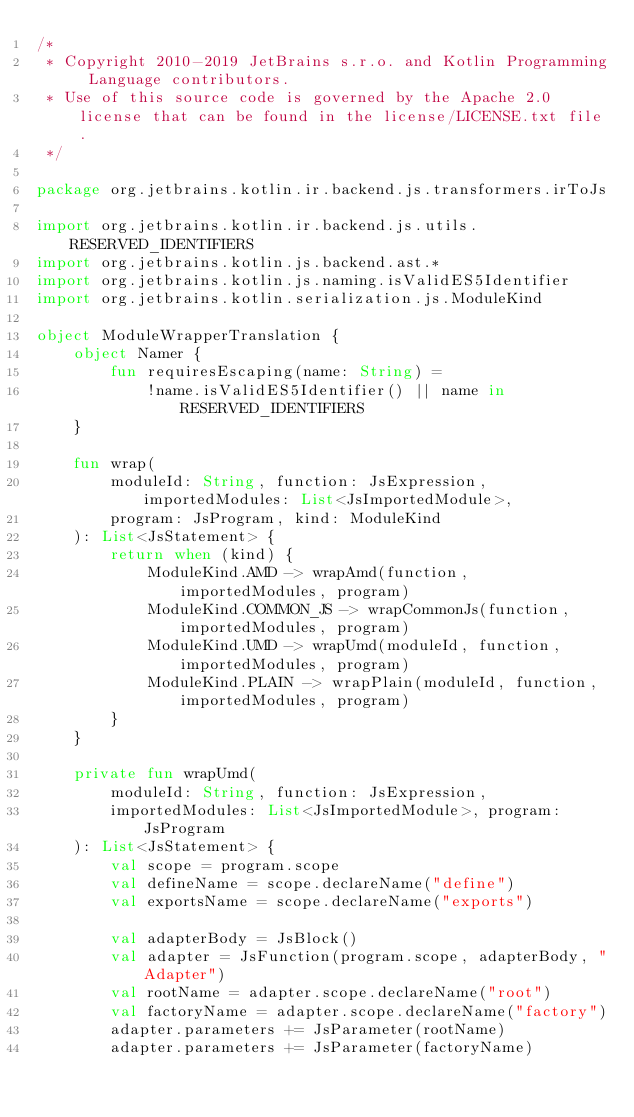Convert code to text. <code><loc_0><loc_0><loc_500><loc_500><_Kotlin_>/*
 * Copyright 2010-2019 JetBrains s.r.o. and Kotlin Programming Language contributors.
 * Use of this source code is governed by the Apache 2.0 license that can be found in the license/LICENSE.txt file.
 */

package org.jetbrains.kotlin.ir.backend.js.transformers.irToJs

import org.jetbrains.kotlin.ir.backend.js.utils.RESERVED_IDENTIFIERS
import org.jetbrains.kotlin.js.backend.ast.*
import org.jetbrains.kotlin.js.naming.isValidES5Identifier
import org.jetbrains.kotlin.serialization.js.ModuleKind

object ModuleWrapperTranslation {
    object Namer {
        fun requiresEscaping(name: String) =
            !name.isValidES5Identifier() || name in RESERVED_IDENTIFIERS
    }

    fun wrap(
        moduleId: String, function: JsExpression, importedModules: List<JsImportedModule>,
        program: JsProgram, kind: ModuleKind
    ): List<JsStatement> {
        return when (kind) {
            ModuleKind.AMD -> wrapAmd(function, importedModules, program)
            ModuleKind.COMMON_JS -> wrapCommonJs(function, importedModules, program)
            ModuleKind.UMD -> wrapUmd(moduleId, function, importedModules, program)
            ModuleKind.PLAIN -> wrapPlain(moduleId, function, importedModules, program)
        }
    }

    private fun wrapUmd(
        moduleId: String, function: JsExpression,
        importedModules: List<JsImportedModule>, program: JsProgram
    ): List<JsStatement> {
        val scope = program.scope
        val defineName = scope.declareName("define")
        val exportsName = scope.declareName("exports")

        val adapterBody = JsBlock()
        val adapter = JsFunction(program.scope, adapterBody, "Adapter")
        val rootName = adapter.scope.declareName("root")
        val factoryName = adapter.scope.declareName("factory")
        adapter.parameters += JsParameter(rootName)
        adapter.parameters += JsParameter(factoryName)
</code> 